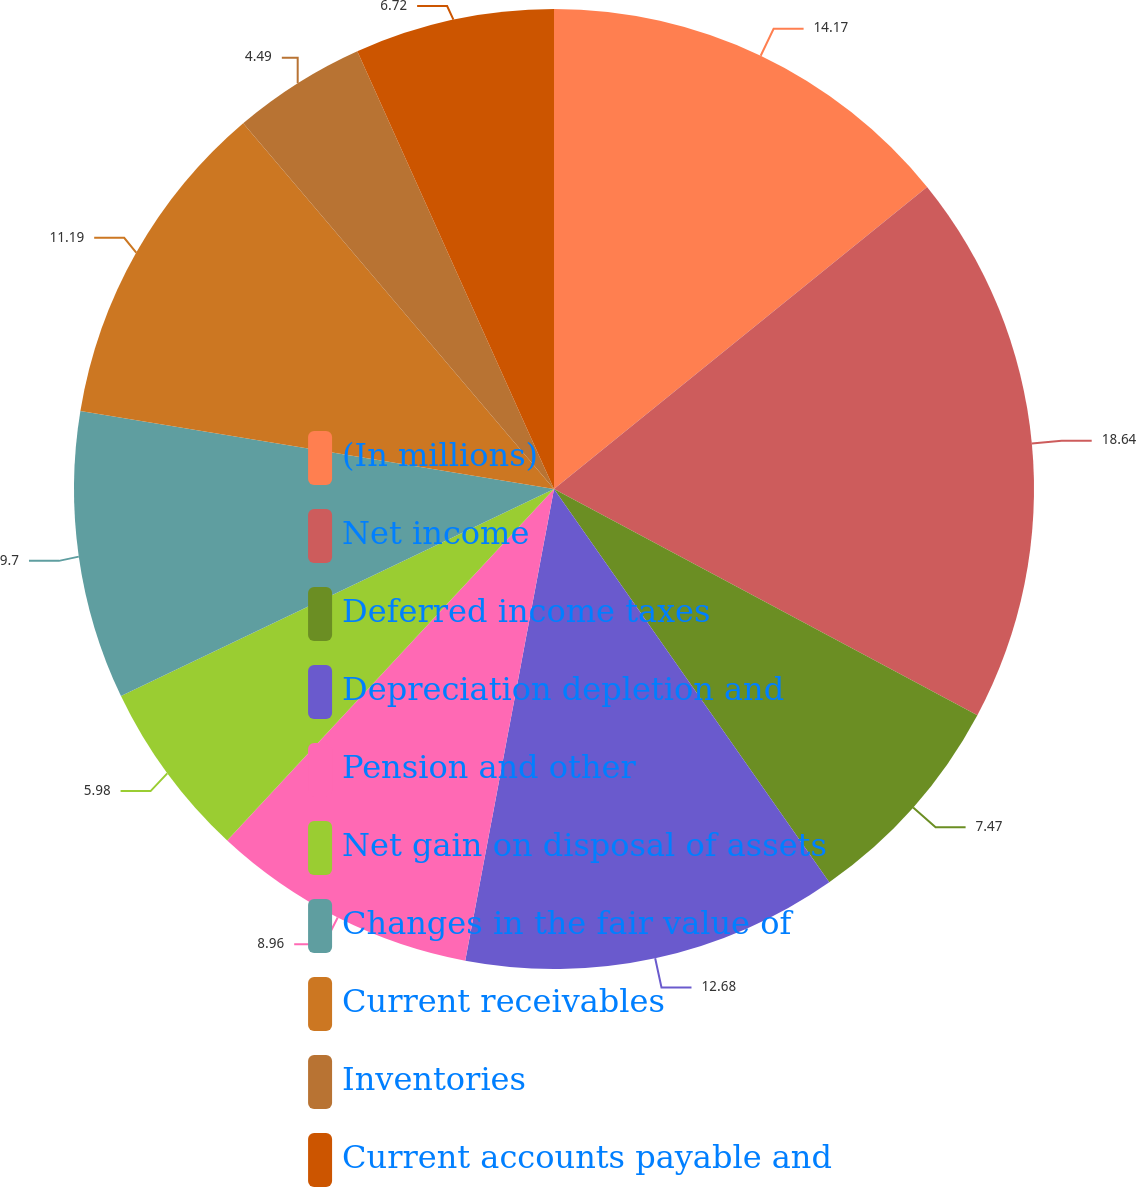Convert chart. <chart><loc_0><loc_0><loc_500><loc_500><pie_chart><fcel>(In millions)<fcel>Net income<fcel>Deferred income taxes<fcel>Depreciation depletion and<fcel>Pension and other<fcel>Net gain on disposal of assets<fcel>Changes in the fair value of<fcel>Current receivables<fcel>Inventories<fcel>Current accounts payable and<nl><fcel>14.17%<fcel>18.64%<fcel>7.47%<fcel>12.68%<fcel>8.96%<fcel>5.98%<fcel>9.7%<fcel>11.19%<fcel>4.49%<fcel>6.72%<nl></chart> 